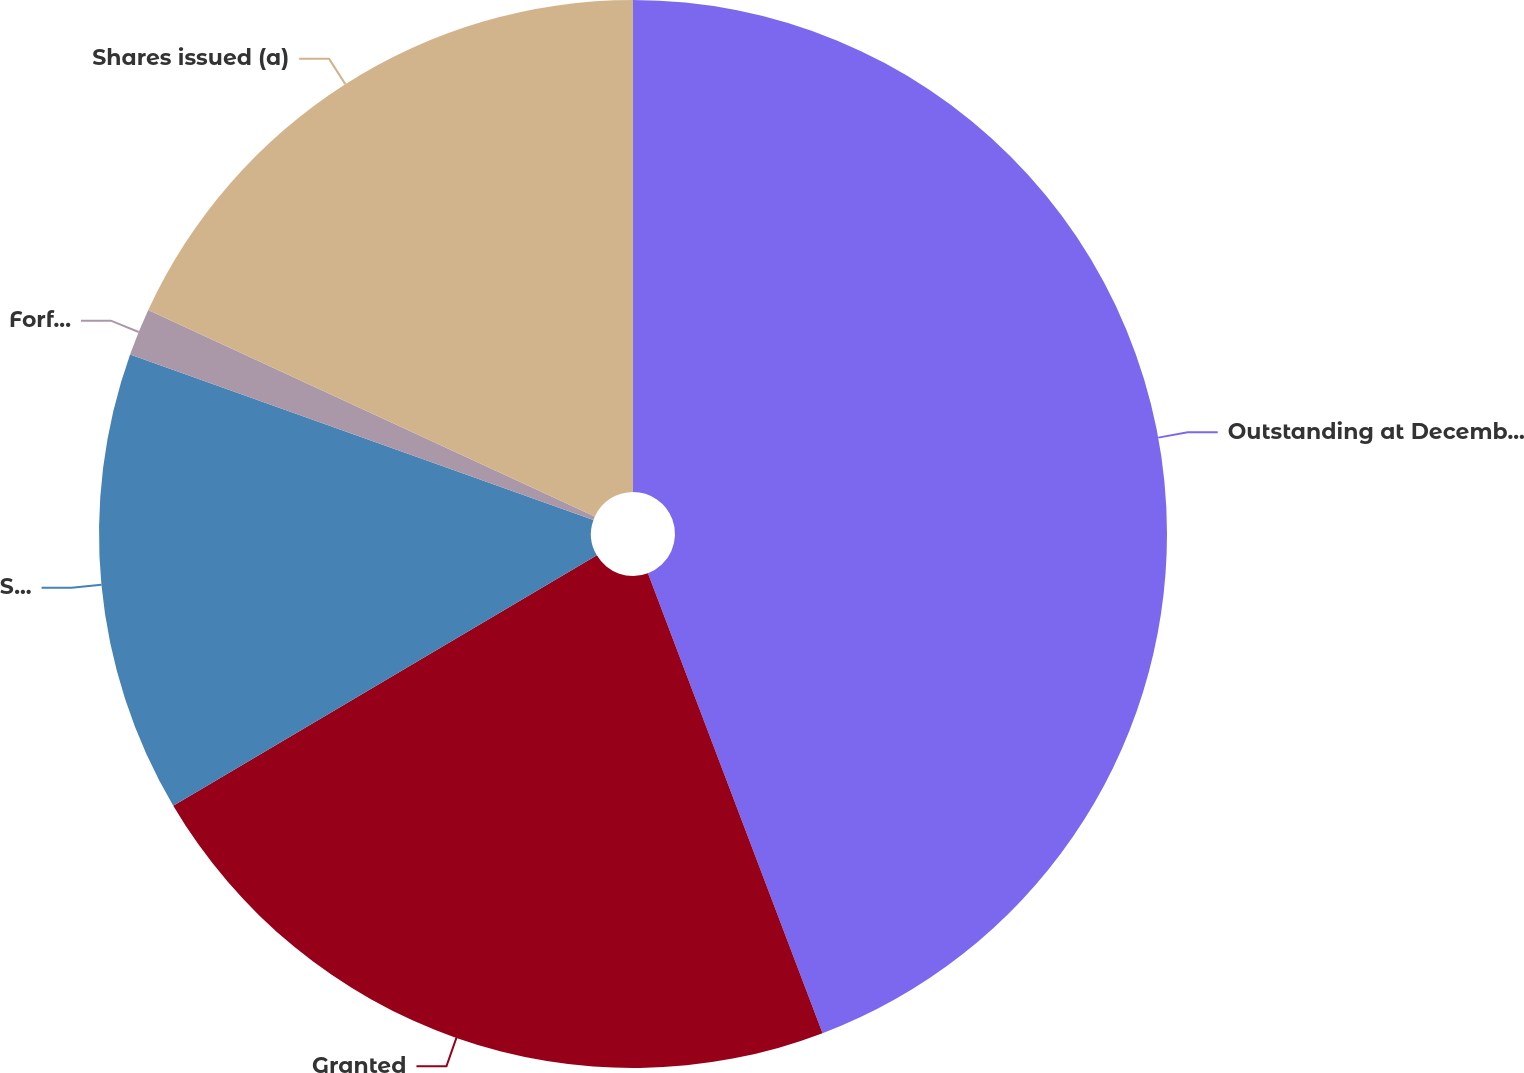Convert chart to OTSL. <chart><loc_0><loc_0><loc_500><loc_500><pie_chart><fcel>Outstanding at December 31<fcel>Granted<fcel>Shares issued<fcel>Forfeited<fcel>Shares issued (a)<nl><fcel>44.22%<fcel>22.28%<fcel>13.95%<fcel>1.43%<fcel>18.11%<nl></chart> 